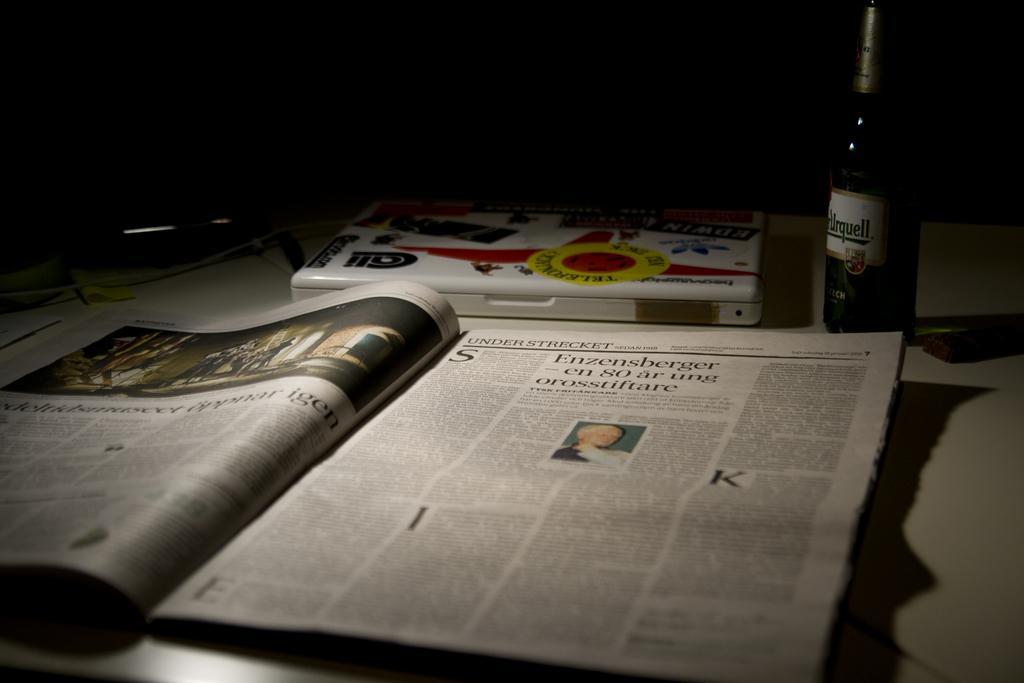In one or two sentences, can you explain what this image depicts? In this picture we can observe a news paper placed on the white color table. We can observe a white color box. There is a bottle on the right side. The background is completely dark. 